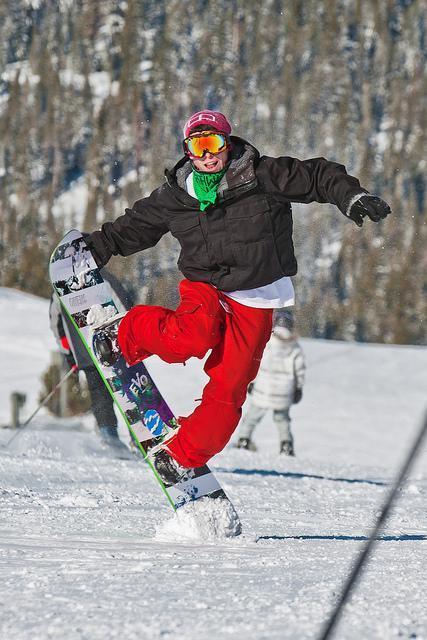How many people can be seen?
Give a very brief answer. 2. How many cars are parked on the street?
Give a very brief answer. 0. 